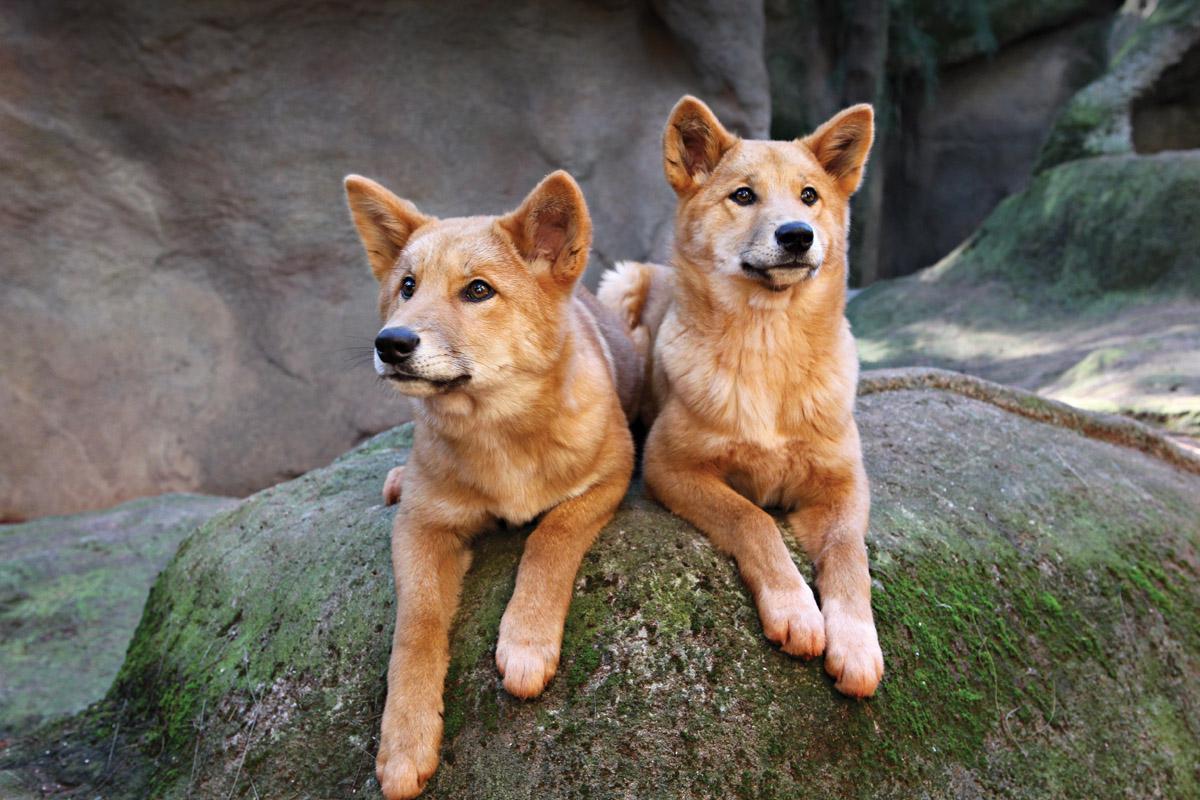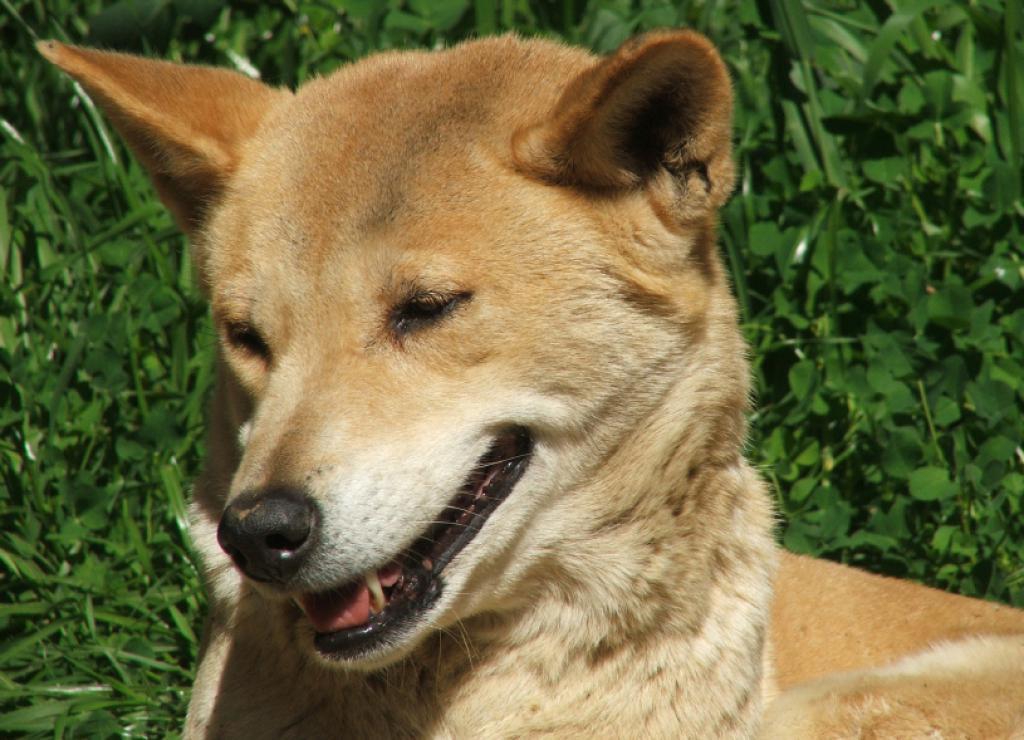The first image is the image on the left, the second image is the image on the right. Evaluate the accuracy of this statement regarding the images: "At least one dog has its teeth visible.". Is it true? Answer yes or no. Yes. The first image is the image on the left, the second image is the image on the right. Examine the images to the left and right. Is the description "Two wild dogs are lying outside in the image on the left." accurate? Answer yes or no. Yes. The first image is the image on the left, the second image is the image on the right. Given the left and right images, does the statement "Two orange dogs are reclining in similar positions near one another." hold true? Answer yes or no. Yes. 